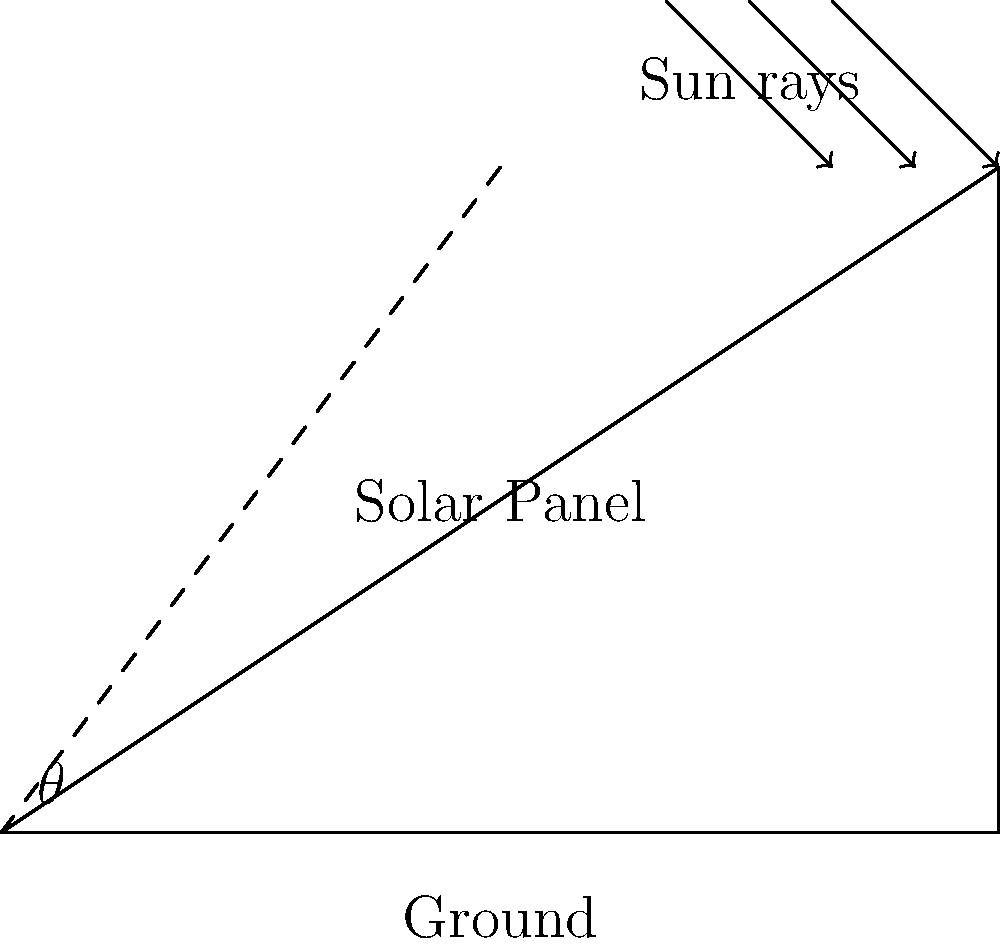The solar panels on your restaurant's roof need to be installed at an optimal angle for maximum energy absorption. If the roof has a 33.7° slope and the ideal angle for the solar panels in your location is 40° from the horizontal, what is the angle $\theta$ at which the solar panels should be tilted relative to the roof surface? To find the angle $\theta$ at which the solar panels should be tilted relative to the roof surface, we need to follow these steps:

1) First, let's identify the known angles:
   - Roof slope: 33.7°
   - Ideal angle for solar panels from horizontal: 40°

2) The angle we're looking for ($\theta$) is the difference between the ideal angle and the roof slope:

   $\theta = \text{Ideal angle} - \text{Roof slope}$

3) Substituting the values:

   $\theta = 40° - 33.7°$

4) Calculating the difference:

   $\theta = 6.3°$

Therefore, the solar panels should be tilted at an angle of 6.3° relative to the roof surface to achieve the optimal 40° angle from the horizontal.
Answer: 6.3° 